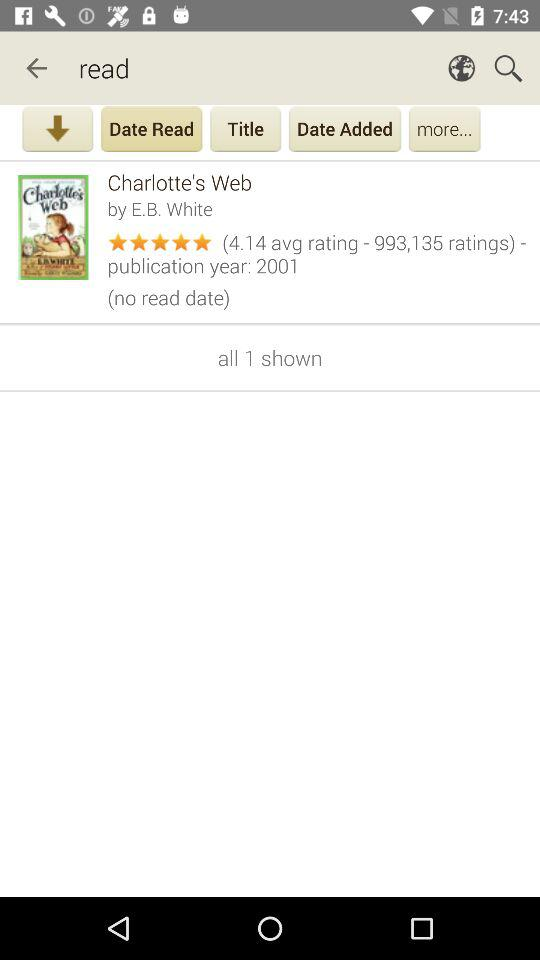Who is the author of "Charlotte's Web"? The author of "Charlotte's Web" is E.B. White. 